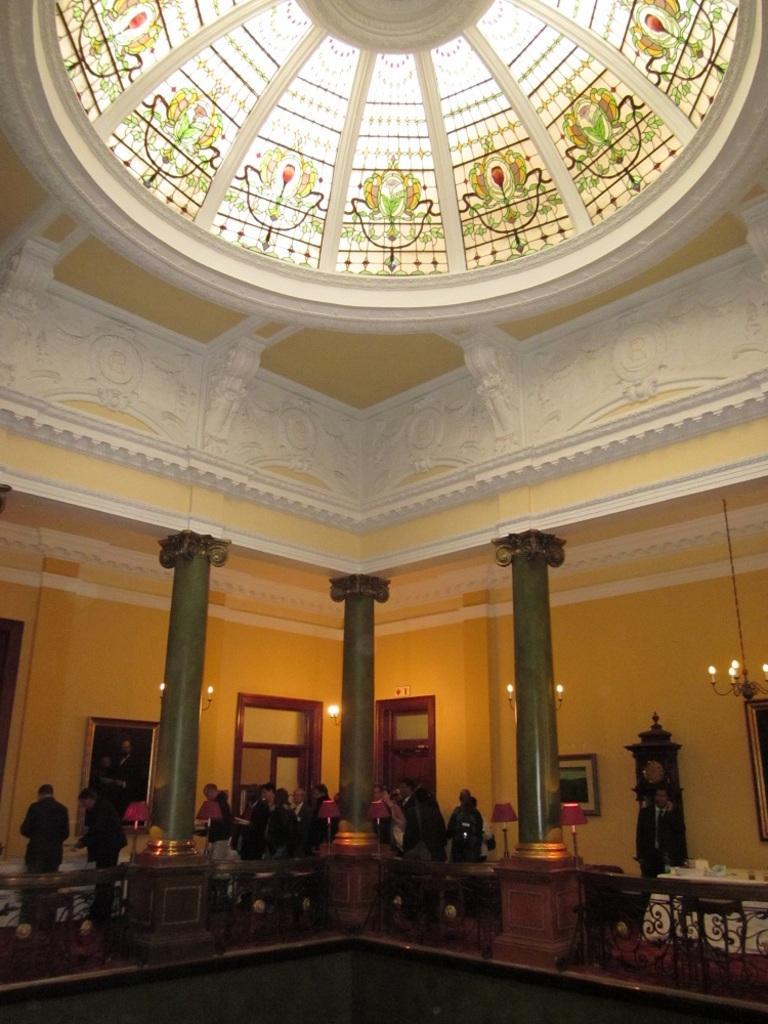Could you give a brief overview of what you see in this image? In this image we can see inside of a building. Also there are pillars and railings. There are people and we can see lamps. Also there are chandeliers. On the ceiling there are glass panes with paintings. And we can see clock. Also there is a photo frame on the wall. And there are doors and windows. 